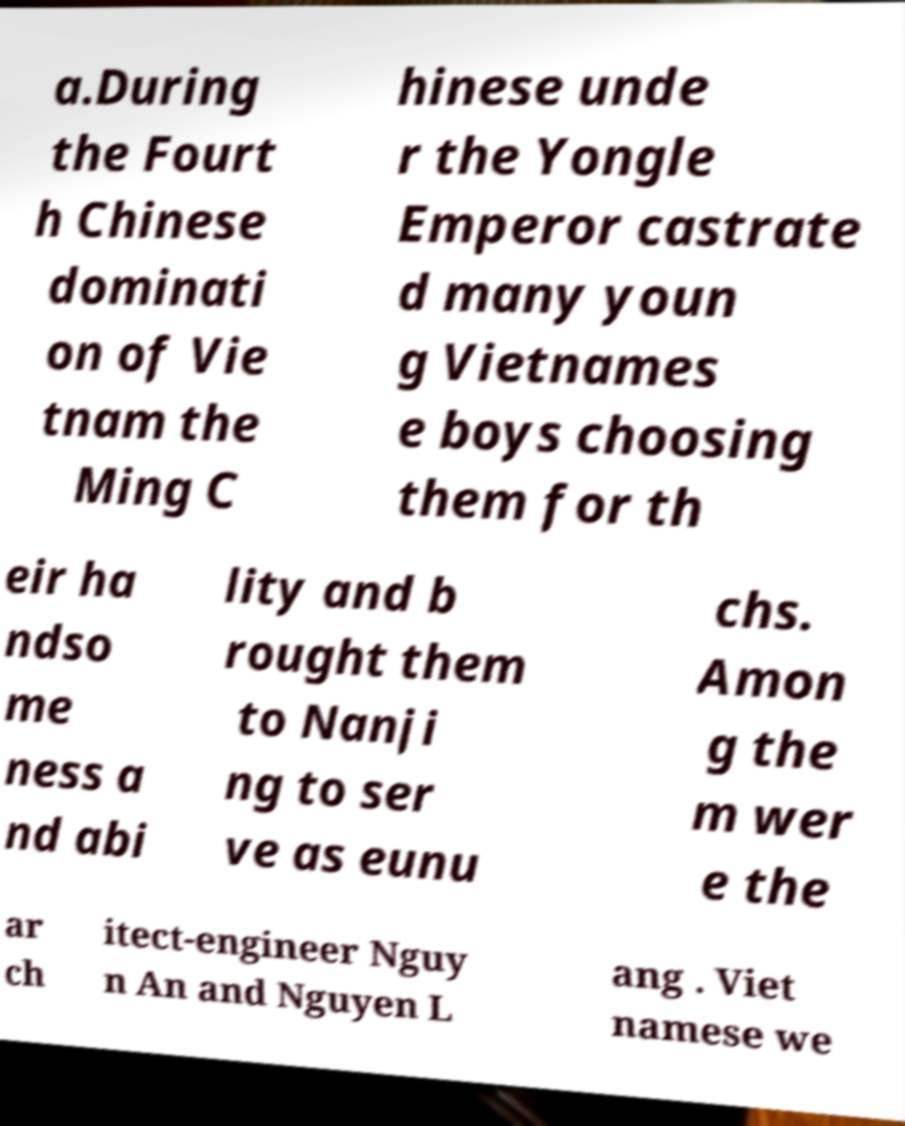Could you assist in decoding the text presented in this image and type it out clearly? a.During the Fourt h Chinese dominati on of Vie tnam the Ming C hinese unde r the Yongle Emperor castrate d many youn g Vietnames e boys choosing them for th eir ha ndso me ness a nd abi lity and b rought them to Nanji ng to ser ve as eunu chs. Amon g the m wer e the ar ch itect-engineer Nguy n An and Nguyen L ang . Viet namese we 